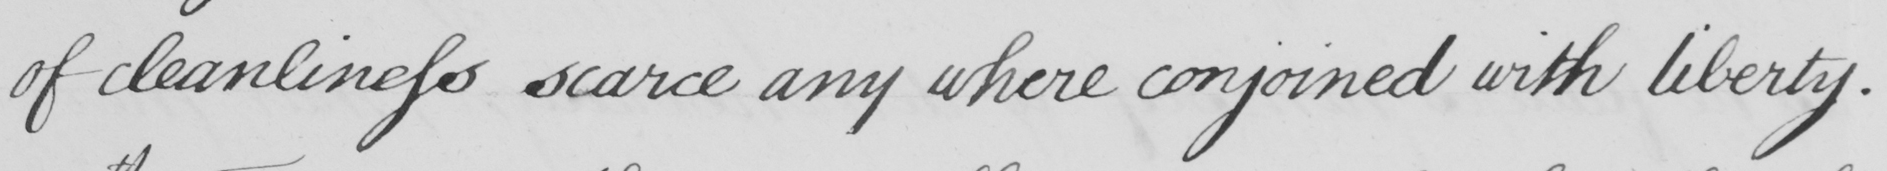Can you tell me what this handwritten text says? of cleanliness scarce any where conjoined with liberty. 